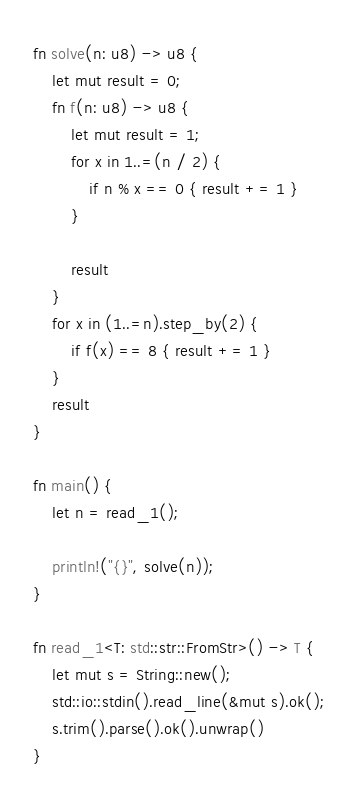Convert code to text. <code><loc_0><loc_0><loc_500><loc_500><_Rust_>fn solve(n: u8) -> u8 {
    let mut result = 0;
    fn f(n: u8) -> u8 {
        let mut result = 1;
        for x in 1..=(n / 2) {
            if n % x == 0 { result += 1 }
        }

        result
    }
    for x in (1..=n).step_by(2) {
        if f(x) == 8 { result += 1 }
    }
    result
}

fn main() {
    let n = read_1();

    println!("{}", solve(n));
}

fn read_1<T: std::str::FromStr>() -> T {
    let mut s = String::new();
    std::io::stdin().read_line(&mut s).ok();
    s.trim().parse().ok().unwrap()
}
</code> 